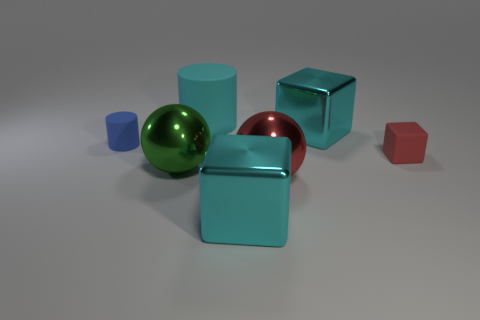Add 2 red metallic things. How many objects exist? 9 Subtract all cylinders. How many objects are left? 5 Add 6 blue cylinders. How many blue cylinders exist? 7 Subtract 0 yellow cylinders. How many objects are left? 7 Subtract all green metal blocks. Subtract all small blue things. How many objects are left? 6 Add 4 cyan things. How many cyan things are left? 7 